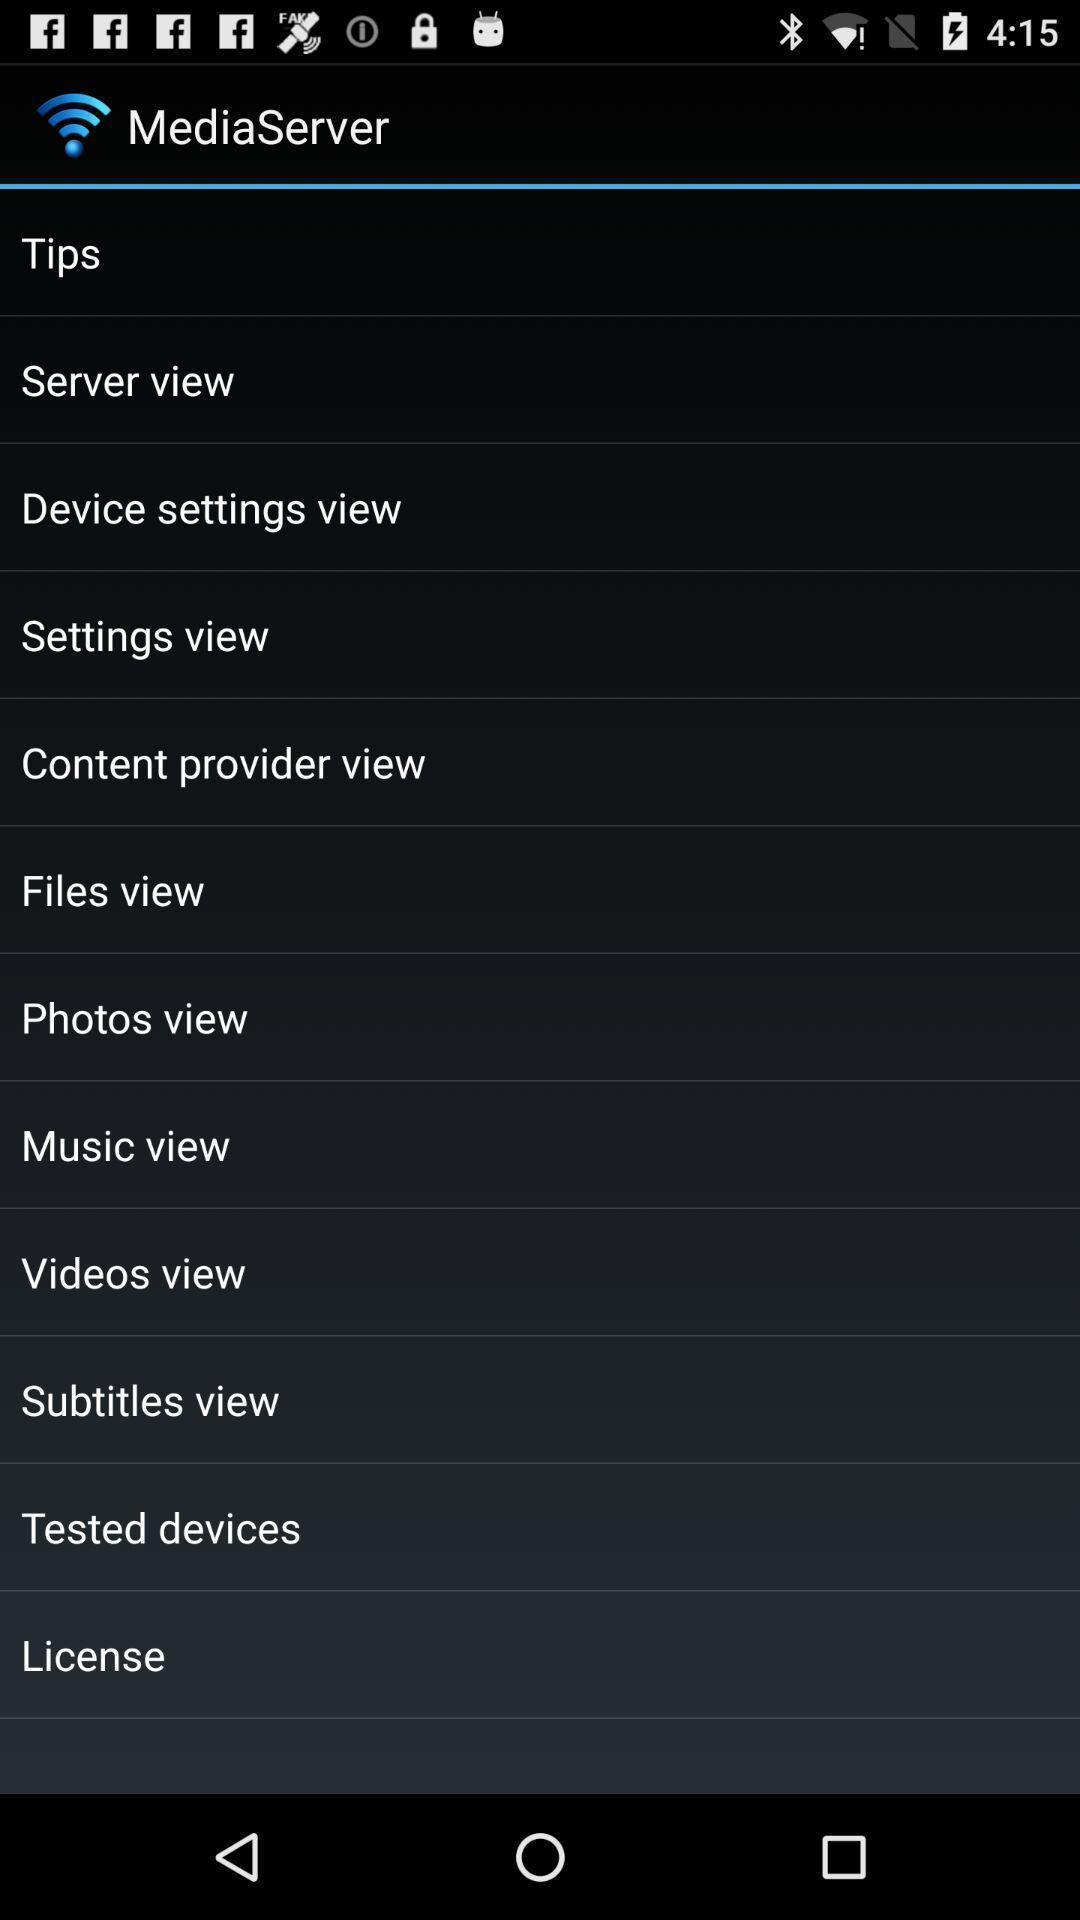Describe the content in this image. Screen displaying the list of options for network. 